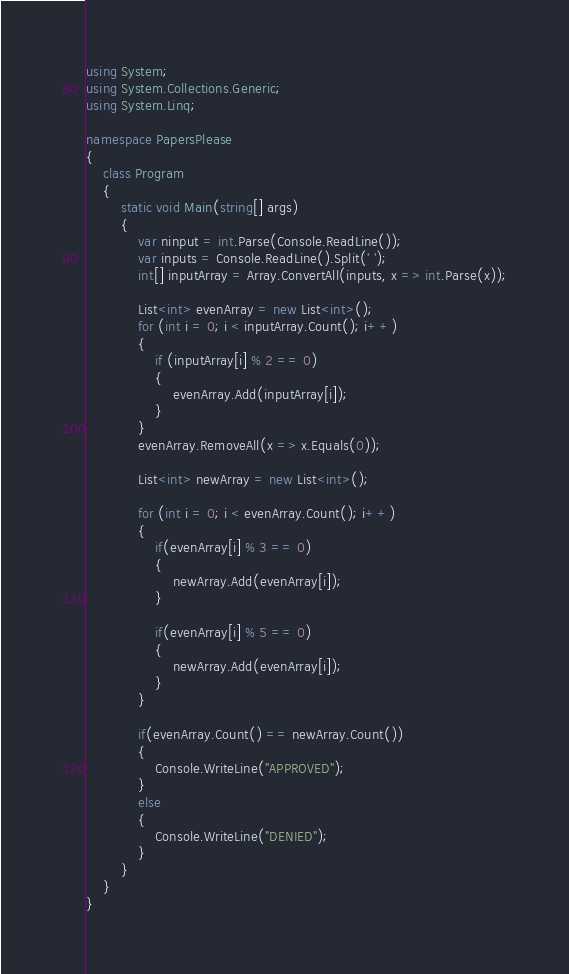<code> <loc_0><loc_0><loc_500><loc_500><_C#_>using System;
using System.Collections.Generic;
using System.Linq;

namespace PapersPlease
{
    class Program
    {
        static void Main(string[] args)
        {
            var ninput = int.Parse(Console.ReadLine());
            var inputs = Console.ReadLine().Split(' ');
            int[] inputArray = Array.ConvertAll(inputs, x => int.Parse(x));

            List<int> evenArray = new List<int>();
            for (int i = 0; i < inputArray.Count(); i++)
            {
                if (inputArray[i] % 2 == 0)
                {
                    evenArray.Add(inputArray[i]);
                }
            }
            evenArray.RemoveAll(x => x.Equals(0));

            List<int> newArray = new List<int>();

            for (int i = 0; i < evenArray.Count(); i++)
            {
                if(evenArray[i] % 3 == 0)
                {
                    newArray.Add(evenArray[i]);
                }

                if(evenArray[i] % 5 == 0)
                {
                    newArray.Add(evenArray[i]);
                }
            }

            if(evenArray.Count() == newArray.Count())
            {
                Console.WriteLine("APPROVED");
            }
            else
            {
                Console.WriteLine("DENIED");
            }            
        }
    }
}
</code> 